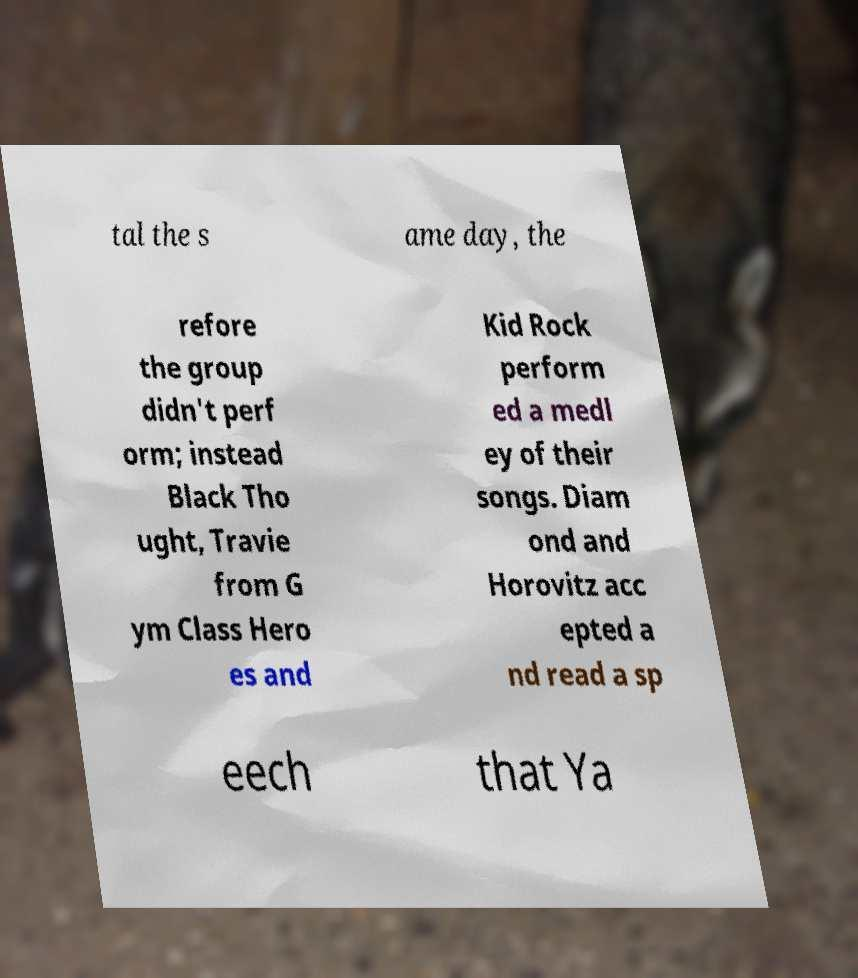There's text embedded in this image that I need extracted. Can you transcribe it verbatim? tal the s ame day, the refore the group didn't perf orm; instead Black Tho ught, Travie from G ym Class Hero es and Kid Rock perform ed a medl ey of their songs. Diam ond and Horovitz acc epted a nd read a sp eech that Ya 